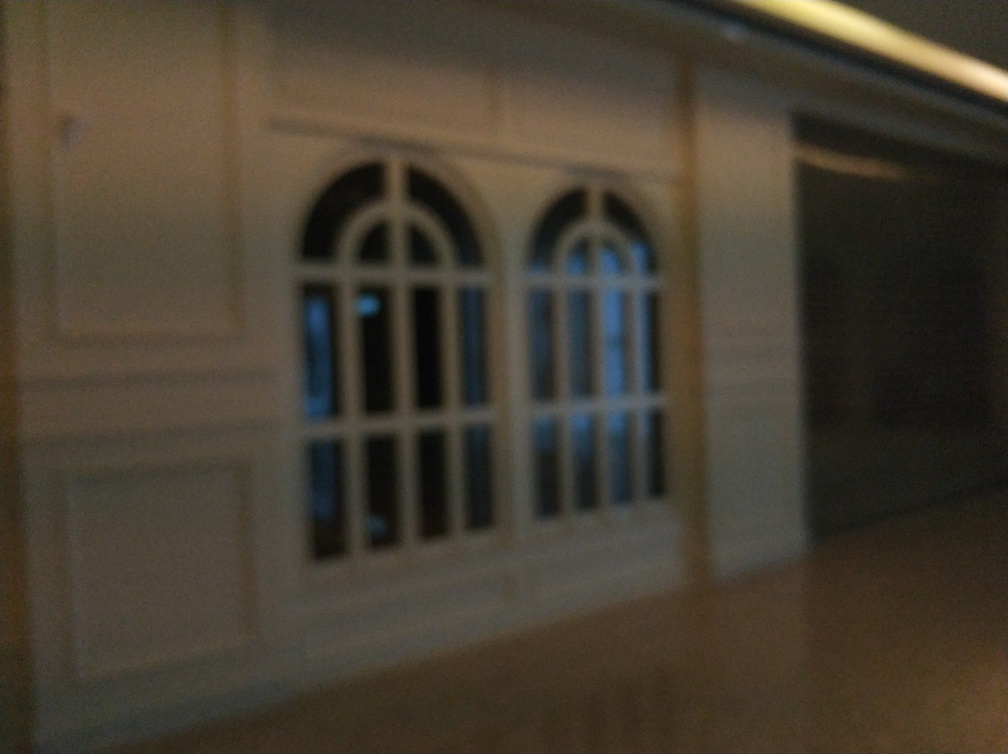What time of day do you think this photo was taken? Given the dim lighting and the illuminated windows, it appears that the photo might have been taken during the evening or at night. 